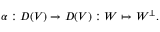<formula> <loc_0><loc_0><loc_500><loc_500>\alpha \colon D ( V ) \rightarrow D ( V ) \colon W \mapsto W ^ { \perp } .</formula> 